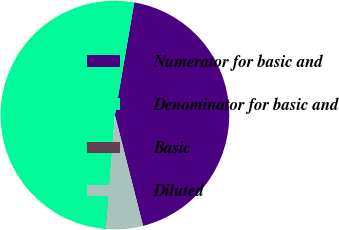<chart> <loc_0><loc_0><loc_500><loc_500><pie_chart><fcel>Numerator for basic and<fcel>Denominator for basic and<fcel>Basic<fcel>Diluted<nl><fcel>43.34%<fcel>51.42%<fcel>0.06%<fcel>5.19%<nl></chart> 